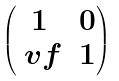Convert formula to latex. <formula><loc_0><loc_0><loc_500><loc_500>\begin{pmatrix} 1 & 0 \\ \ v f & 1 \end{pmatrix}</formula> 